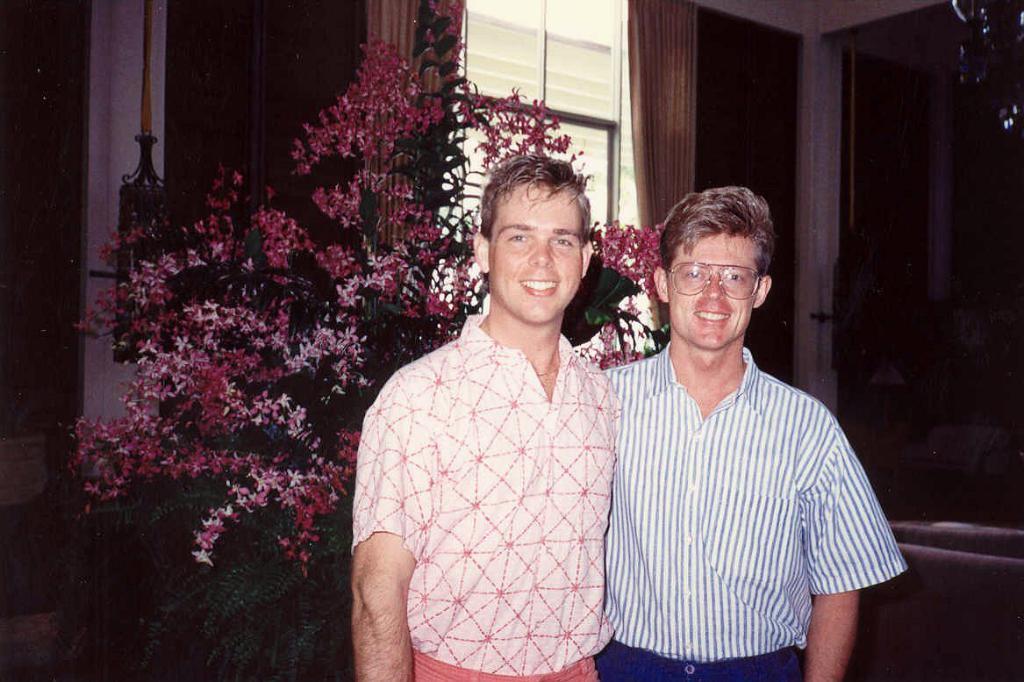In one or two sentences, can you explain what this image depicts? In this picture there are two boys in the center of the image and there is plant, on which there are many flowers behind them and there are doors, a window and curtain in the background area of the image, there is sofa at the bottom side of the image. 